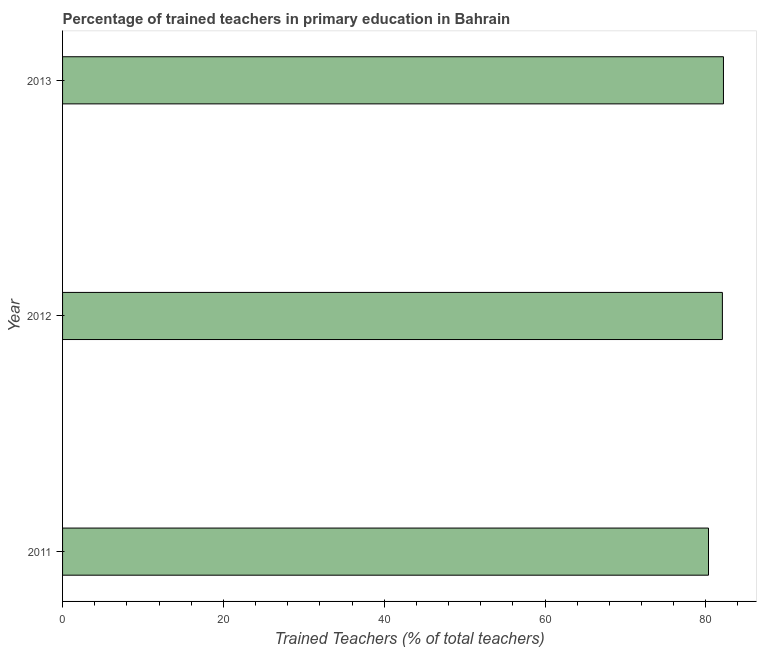Does the graph contain grids?
Keep it short and to the point. No. What is the title of the graph?
Give a very brief answer. Percentage of trained teachers in primary education in Bahrain. What is the label or title of the X-axis?
Offer a very short reply. Trained Teachers (% of total teachers). What is the percentage of trained teachers in 2012?
Keep it short and to the point. 82.06. Across all years, what is the maximum percentage of trained teachers?
Ensure brevity in your answer.  82.19. Across all years, what is the minimum percentage of trained teachers?
Provide a succinct answer. 80.34. In which year was the percentage of trained teachers maximum?
Provide a succinct answer. 2013. What is the sum of the percentage of trained teachers?
Keep it short and to the point. 244.59. What is the difference between the percentage of trained teachers in 2011 and 2013?
Keep it short and to the point. -1.86. What is the average percentage of trained teachers per year?
Your response must be concise. 81.53. What is the median percentage of trained teachers?
Provide a succinct answer. 82.06. Do a majority of the years between 2013 and 2012 (inclusive) have percentage of trained teachers greater than 48 %?
Offer a very short reply. No. Is the percentage of trained teachers in 2011 less than that in 2012?
Your response must be concise. Yes. What is the difference between the highest and the second highest percentage of trained teachers?
Provide a succinct answer. 0.13. Is the sum of the percentage of trained teachers in 2011 and 2012 greater than the maximum percentage of trained teachers across all years?
Make the answer very short. Yes. What is the difference between the highest and the lowest percentage of trained teachers?
Provide a succinct answer. 1.86. In how many years, is the percentage of trained teachers greater than the average percentage of trained teachers taken over all years?
Give a very brief answer. 2. Are the values on the major ticks of X-axis written in scientific E-notation?
Ensure brevity in your answer.  No. What is the Trained Teachers (% of total teachers) of 2011?
Give a very brief answer. 80.34. What is the Trained Teachers (% of total teachers) in 2012?
Ensure brevity in your answer.  82.06. What is the Trained Teachers (% of total teachers) of 2013?
Keep it short and to the point. 82.19. What is the difference between the Trained Teachers (% of total teachers) in 2011 and 2012?
Offer a terse response. -1.73. What is the difference between the Trained Teachers (% of total teachers) in 2011 and 2013?
Offer a terse response. -1.86. What is the difference between the Trained Teachers (% of total teachers) in 2012 and 2013?
Ensure brevity in your answer.  -0.13. 